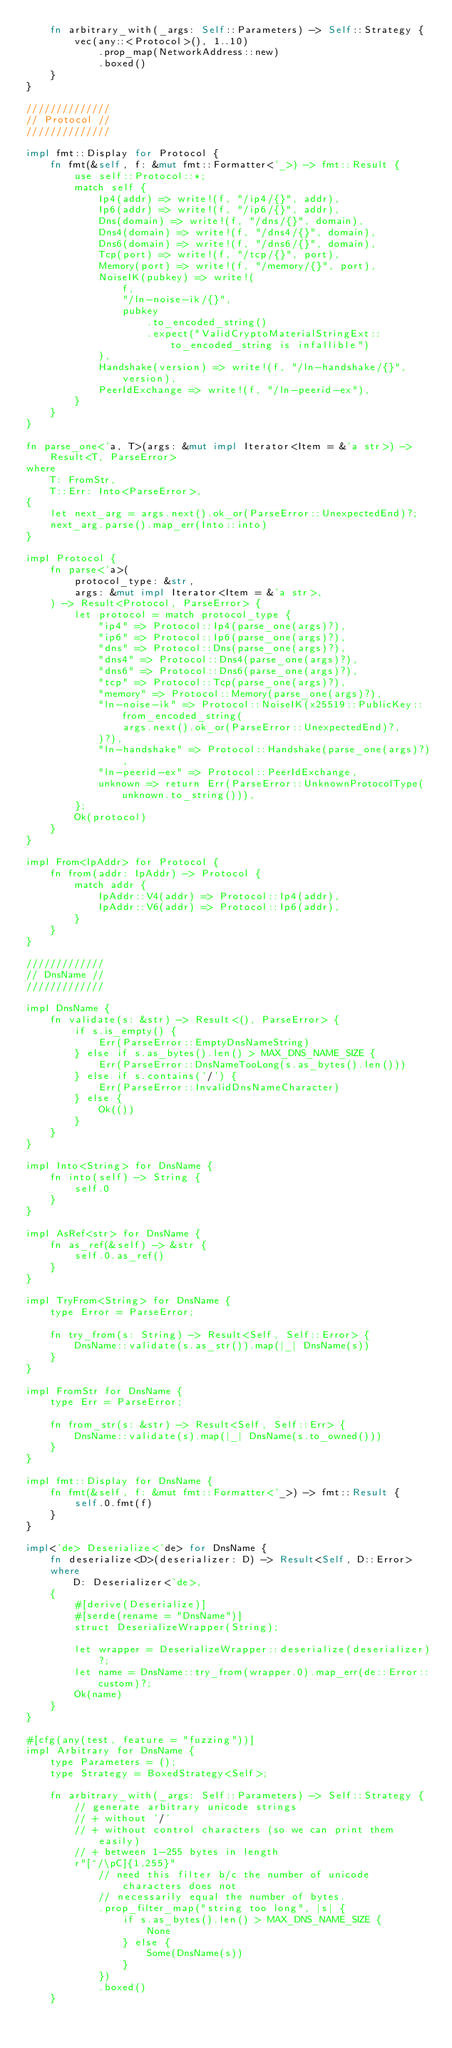Convert code to text. <code><loc_0><loc_0><loc_500><loc_500><_Rust_>    fn arbitrary_with(_args: Self::Parameters) -> Self::Strategy {
        vec(any::<Protocol>(), 1..10)
            .prop_map(NetworkAddress::new)
            .boxed()
    }
}

//////////////
// Protocol //
//////////////

impl fmt::Display for Protocol {
    fn fmt(&self, f: &mut fmt::Formatter<'_>) -> fmt::Result {
        use self::Protocol::*;
        match self {
            Ip4(addr) => write!(f, "/ip4/{}", addr),
            Ip6(addr) => write!(f, "/ip6/{}", addr),
            Dns(domain) => write!(f, "/dns/{}", domain),
            Dns4(domain) => write!(f, "/dns4/{}", domain),
            Dns6(domain) => write!(f, "/dns6/{}", domain),
            Tcp(port) => write!(f, "/tcp/{}", port),
            Memory(port) => write!(f, "/memory/{}", port),
            NoiseIK(pubkey) => write!(
                f,
                "/ln-noise-ik/{}",
                pubkey
                    .to_encoded_string()
                    .expect("ValidCryptoMaterialStringExt::to_encoded_string is infallible")
            ),
            Handshake(version) => write!(f, "/ln-handshake/{}", version),
            PeerIdExchange => write!(f, "/ln-peerid-ex"),
        }
    }
}

fn parse_one<'a, T>(args: &mut impl Iterator<Item = &'a str>) -> Result<T, ParseError>
where
    T: FromStr,
    T::Err: Into<ParseError>,
{
    let next_arg = args.next().ok_or(ParseError::UnexpectedEnd)?;
    next_arg.parse().map_err(Into::into)
}

impl Protocol {
    fn parse<'a>(
        protocol_type: &str,
        args: &mut impl Iterator<Item = &'a str>,
    ) -> Result<Protocol, ParseError> {
        let protocol = match protocol_type {
            "ip4" => Protocol::Ip4(parse_one(args)?),
            "ip6" => Protocol::Ip6(parse_one(args)?),
            "dns" => Protocol::Dns(parse_one(args)?),
            "dns4" => Protocol::Dns4(parse_one(args)?),
            "dns6" => Protocol::Dns6(parse_one(args)?),
            "tcp" => Protocol::Tcp(parse_one(args)?),
            "memory" => Protocol::Memory(parse_one(args)?),
            "ln-noise-ik" => Protocol::NoiseIK(x25519::PublicKey::from_encoded_string(
                args.next().ok_or(ParseError::UnexpectedEnd)?,
            )?),
            "ln-handshake" => Protocol::Handshake(parse_one(args)?),
            "ln-peerid-ex" => Protocol::PeerIdExchange,
            unknown => return Err(ParseError::UnknownProtocolType(unknown.to_string())),
        };
        Ok(protocol)
    }
}

impl From<IpAddr> for Protocol {
    fn from(addr: IpAddr) -> Protocol {
        match addr {
            IpAddr::V4(addr) => Protocol::Ip4(addr),
            IpAddr::V6(addr) => Protocol::Ip6(addr),
        }
    }
}

/////////////
// DnsName //
/////////////

impl DnsName {
    fn validate(s: &str) -> Result<(), ParseError> {
        if s.is_empty() {
            Err(ParseError::EmptyDnsNameString)
        } else if s.as_bytes().len() > MAX_DNS_NAME_SIZE {
            Err(ParseError::DnsNameTooLong(s.as_bytes().len()))
        } else if s.contains('/') {
            Err(ParseError::InvalidDnsNameCharacter)
        } else {
            Ok(())
        }
    }
}

impl Into<String> for DnsName {
    fn into(self) -> String {
        self.0
    }
}

impl AsRef<str> for DnsName {
    fn as_ref(&self) -> &str {
        self.0.as_ref()
    }
}

impl TryFrom<String> for DnsName {
    type Error = ParseError;

    fn try_from(s: String) -> Result<Self, Self::Error> {
        DnsName::validate(s.as_str()).map(|_| DnsName(s))
    }
}

impl FromStr for DnsName {
    type Err = ParseError;

    fn from_str(s: &str) -> Result<Self, Self::Err> {
        DnsName::validate(s).map(|_| DnsName(s.to_owned()))
    }
}

impl fmt::Display for DnsName {
    fn fmt(&self, f: &mut fmt::Formatter<'_>) -> fmt::Result {
        self.0.fmt(f)
    }
}

impl<'de> Deserialize<'de> for DnsName {
    fn deserialize<D>(deserializer: D) -> Result<Self, D::Error>
    where
        D: Deserializer<'de>,
    {
        #[derive(Deserialize)]
        #[serde(rename = "DnsName")]
        struct DeserializeWrapper(String);

        let wrapper = DeserializeWrapper::deserialize(deserializer)?;
        let name = DnsName::try_from(wrapper.0).map_err(de::Error::custom)?;
        Ok(name)
    }
}

#[cfg(any(test, feature = "fuzzing"))]
impl Arbitrary for DnsName {
    type Parameters = ();
    type Strategy = BoxedStrategy<Self>;

    fn arbitrary_with(_args: Self::Parameters) -> Self::Strategy {
        // generate arbitrary unicode strings
        // + without '/'
        // + without control characters (so we can print them easily)
        // + between 1-255 bytes in length
        r"[^/\pC]{1,255}"
            // need this filter b/c the number of unicode characters does not
            // necessarily equal the number of bytes.
            .prop_filter_map("string too long", |s| {
                if s.as_bytes().len() > MAX_DNS_NAME_SIZE {
                    None
                } else {
                    Some(DnsName(s))
                }
            })
            .boxed()
    }</code> 